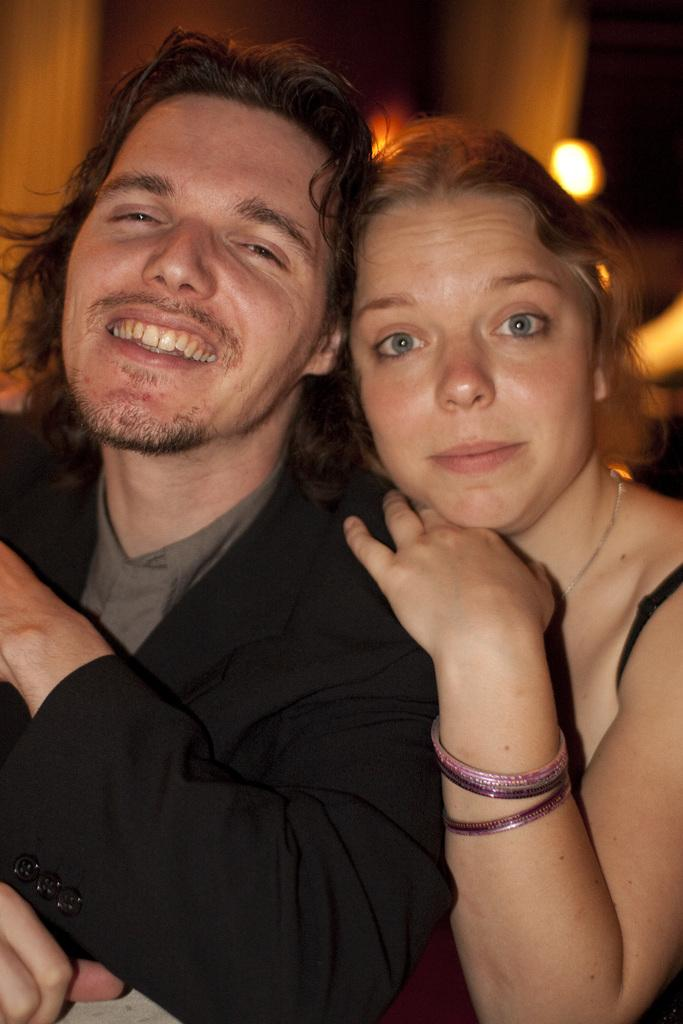How many people are in the image? There are two people in the image, a man and a woman. What is the woman doing in the image? The woman is holding the man. What is the man's expression in the image? The man is smiling. What can be seen in the background of the image? There are lights in the background of the image. How would you describe the background of the image? The background of the image is blurry. What type of ear is visible on the cattle in the image? There are no cattle present in the image, and therefore no ears can be observed. How is the thread being used in the image? There is no thread present in the image. 